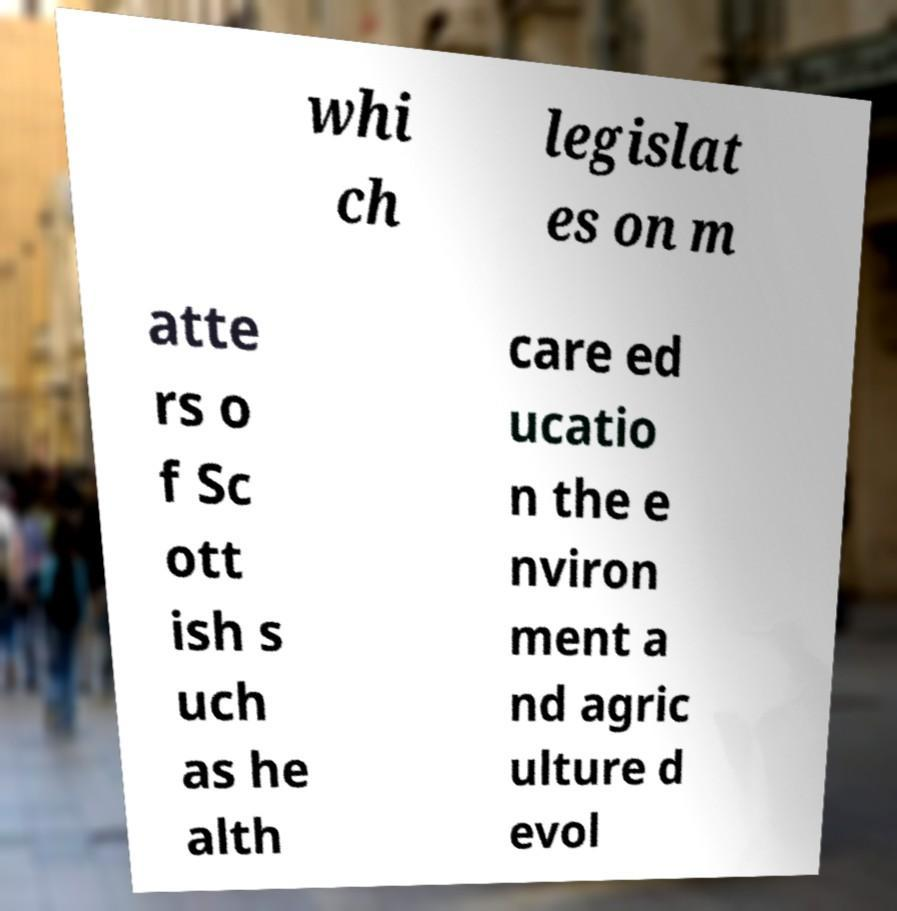I need the written content from this picture converted into text. Can you do that? whi ch legislat es on m atte rs o f Sc ott ish s uch as he alth care ed ucatio n the e nviron ment a nd agric ulture d evol 